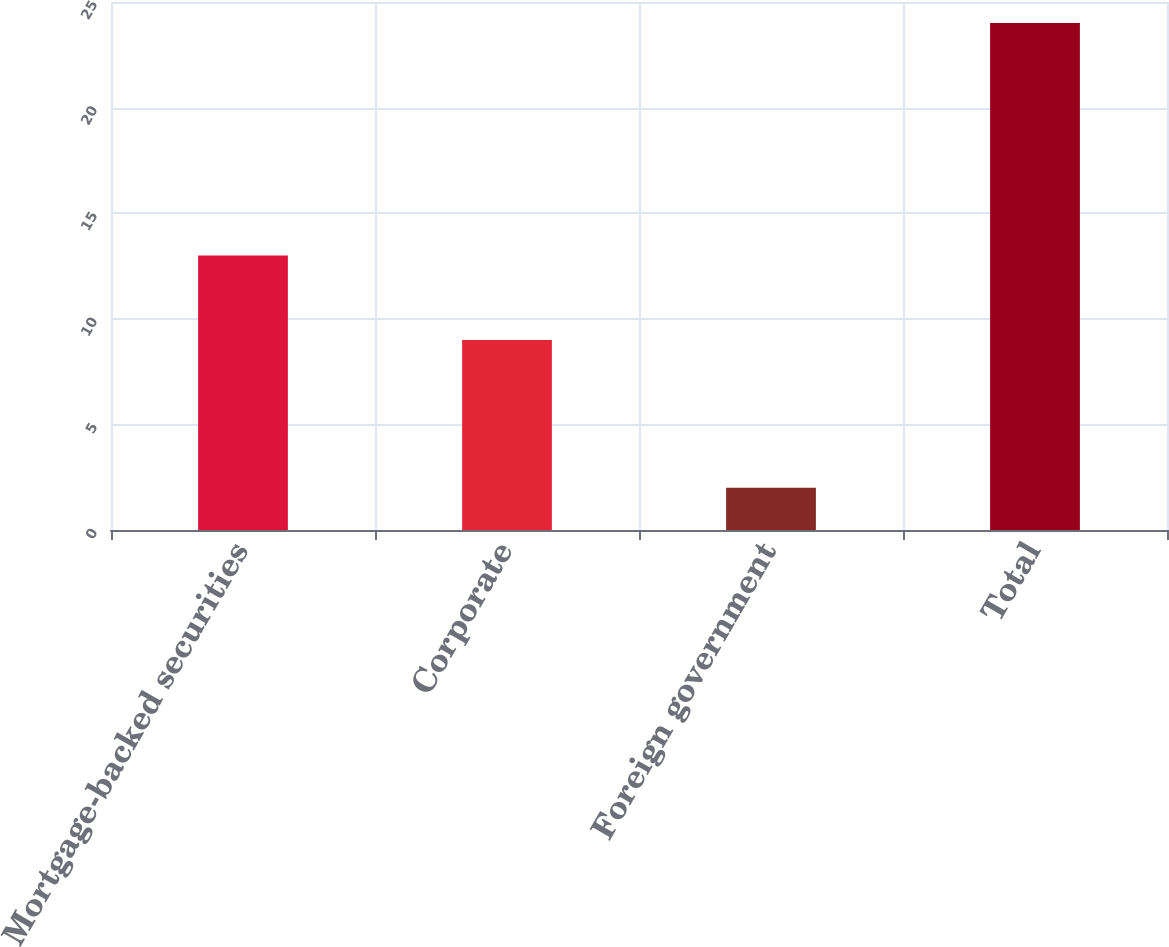Convert chart. <chart><loc_0><loc_0><loc_500><loc_500><bar_chart><fcel>Mortgage-backed securities<fcel>Corporate<fcel>Foreign government<fcel>Total<nl><fcel>13<fcel>9<fcel>2<fcel>24<nl></chart> 